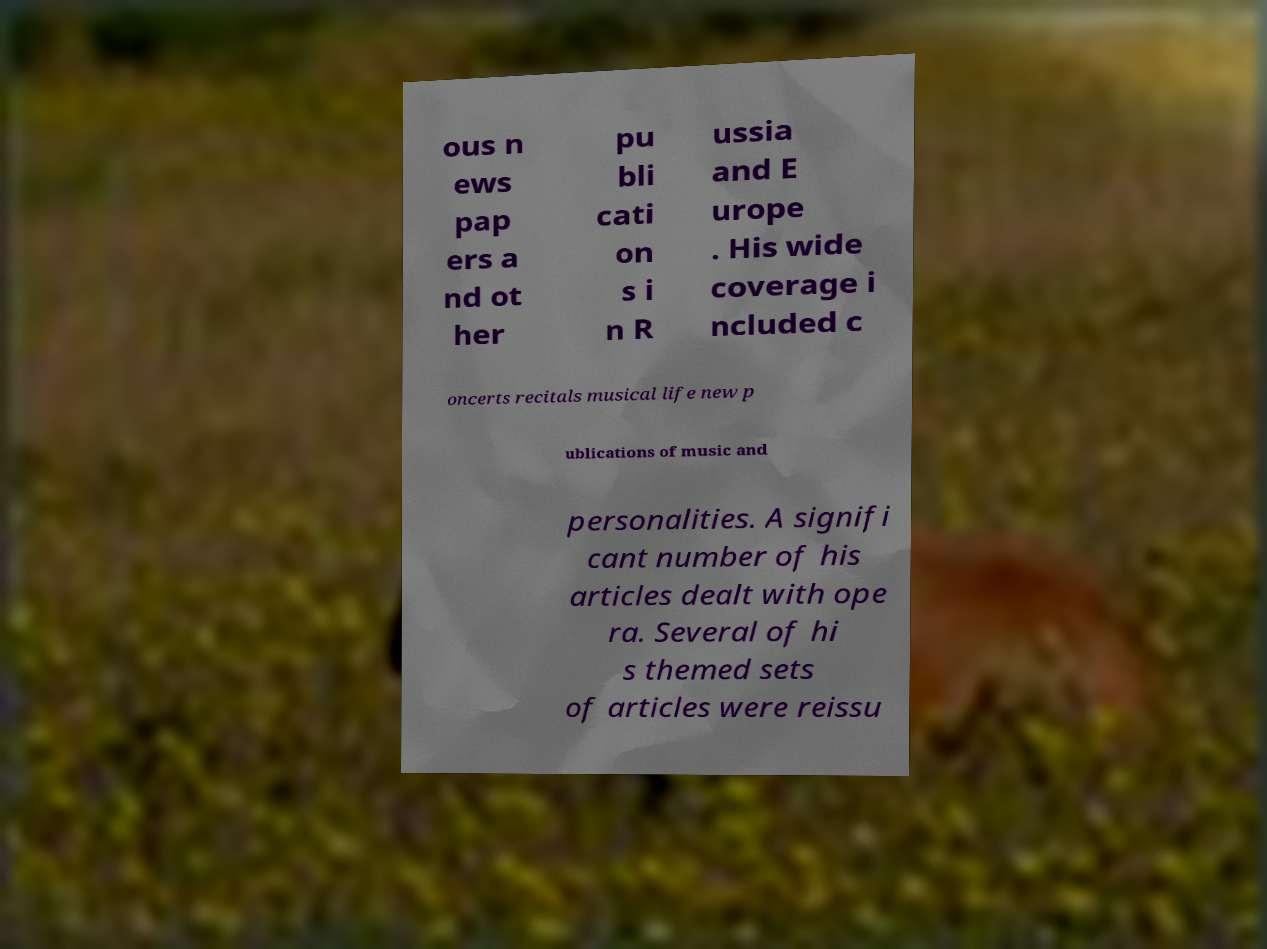Could you assist in decoding the text presented in this image and type it out clearly? ous n ews pap ers a nd ot her pu bli cati on s i n R ussia and E urope . His wide coverage i ncluded c oncerts recitals musical life new p ublications of music and personalities. A signifi cant number of his articles dealt with ope ra. Several of hi s themed sets of articles were reissu 